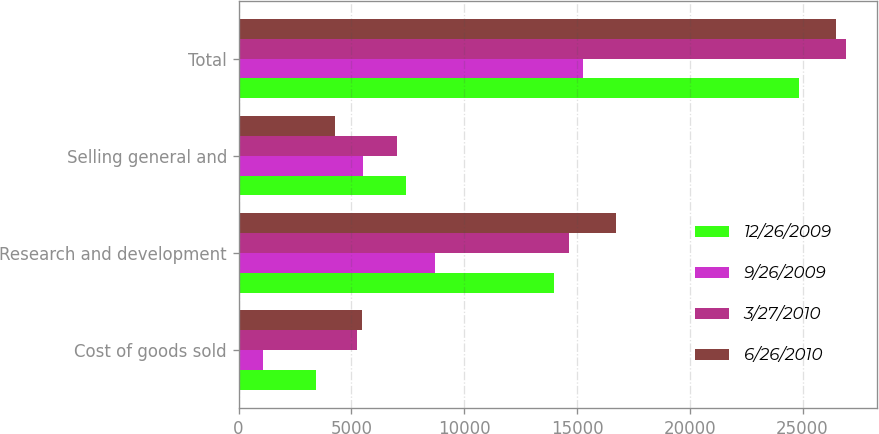Convert chart to OTSL. <chart><loc_0><loc_0><loc_500><loc_500><stacked_bar_chart><ecel><fcel>Cost of goods sold<fcel>Research and development<fcel>Selling general and<fcel>Total<nl><fcel>12/26/2009<fcel>3423<fcel>13983<fcel>7442<fcel>24848<nl><fcel>9/26/2009<fcel>1071<fcel>8691<fcel>5517<fcel>15279<nl><fcel>3/27/2010<fcel>5265<fcel>14650<fcel>7018<fcel>26933<nl><fcel>6/26/2010<fcel>5461<fcel>16741<fcel>4263<fcel>26465<nl></chart> 